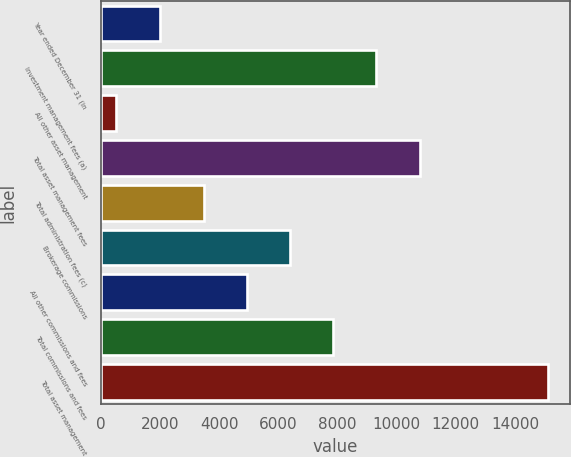<chart> <loc_0><loc_0><loc_500><loc_500><bar_chart><fcel>Year ended December 31 (in<fcel>Investment management fees (a)<fcel>All other asset management<fcel>Total asset management fees<fcel>Total administration fees (c)<fcel>Brokerage commissions<fcel>All other commissions and fees<fcel>Total commissions and fees<fcel>Total asset management<nl><fcel>2013<fcel>9313.5<fcel>505<fcel>10773.6<fcel>3473.1<fcel>6393.3<fcel>4933.2<fcel>7853.4<fcel>15106<nl></chart> 